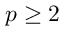Convert formula to latex. <formula><loc_0><loc_0><loc_500><loc_500>p \geq 2</formula> 